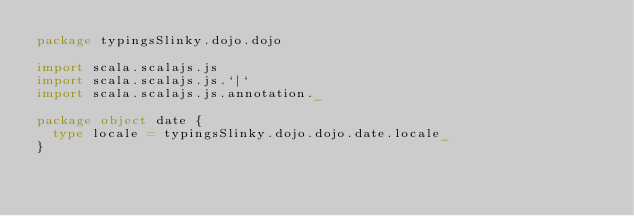Convert code to text. <code><loc_0><loc_0><loc_500><loc_500><_Scala_>package typingsSlinky.dojo.dojo

import scala.scalajs.js
import scala.scalajs.js.`|`
import scala.scalajs.js.annotation._

package object date {
  type locale = typingsSlinky.dojo.dojo.date.locale_
}
</code> 